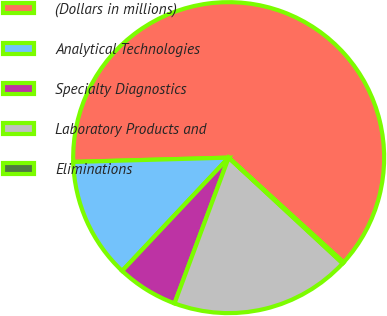<chart> <loc_0><loc_0><loc_500><loc_500><pie_chart><fcel>(Dollars in millions)<fcel>Analytical Technologies<fcel>Specialty Diagnostics<fcel>Laboratory Products and<fcel>Eliminations<nl><fcel>62.2%<fcel>12.55%<fcel>6.35%<fcel>18.76%<fcel>0.14%<nl></chart> 